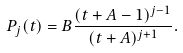<formula> <loc_0><loc_0><loc_500><loc_500>P _ { j } ( t ) = B \frac { ( t + A - 1 ) ^ { j - 1 } } { ( t + A ) ^ { j + 1 } } .</formula> 